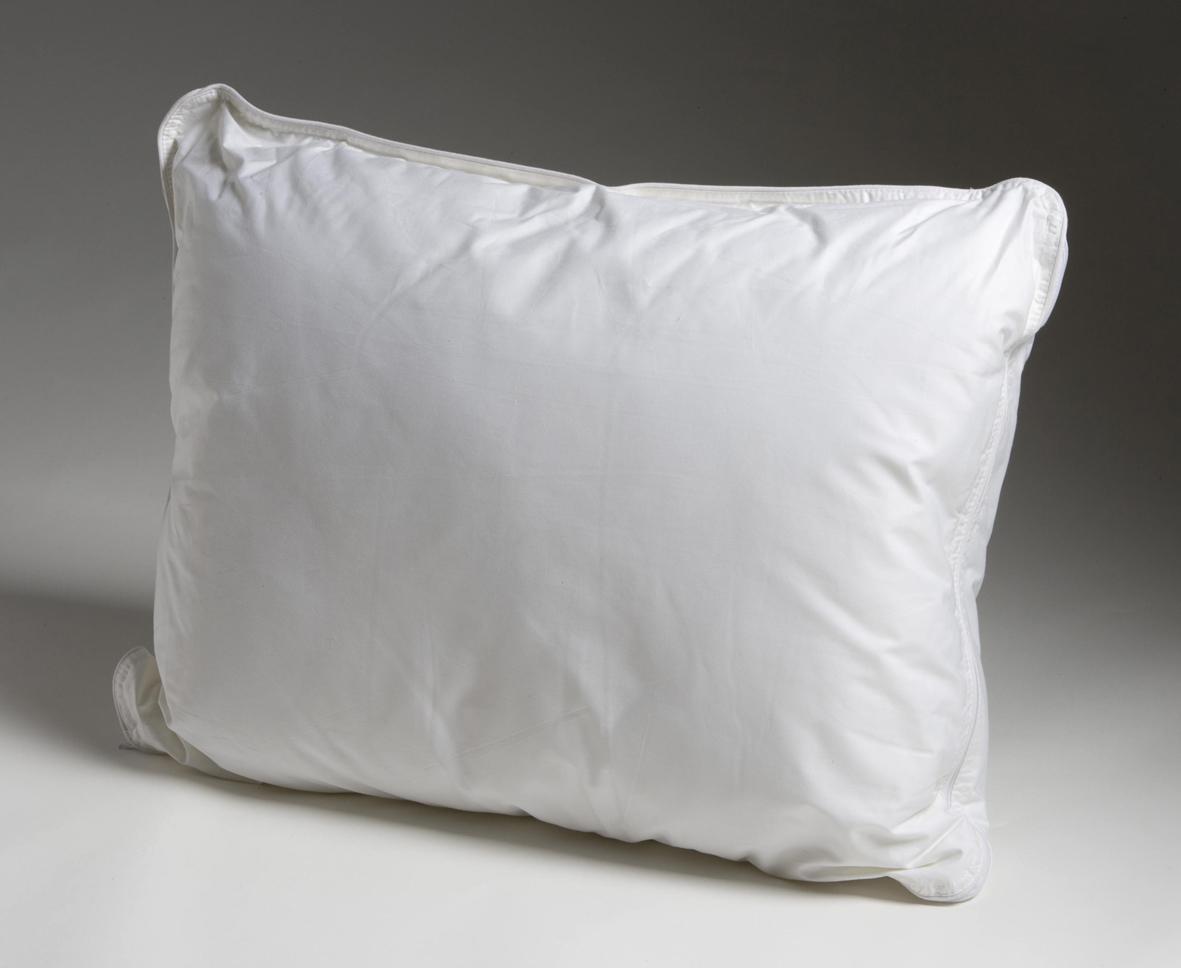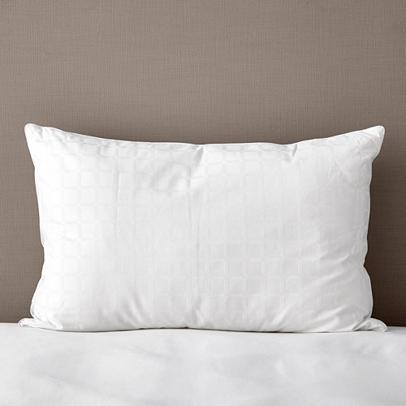The first image is the image on the left, the second image is the image on the right. Examine the images to the left and right. Is the description "There are at most 3 pillows in the pair of images." accurate? Answer yes or no. Yes. The first image is the image on the left, the second image is the image on the right. For the images displayed, is the sentence "An image contains exactly three white pillows, and an image shows multiple pillows on a bed with a white blanket." factually correct? Answer yes or no. No. 